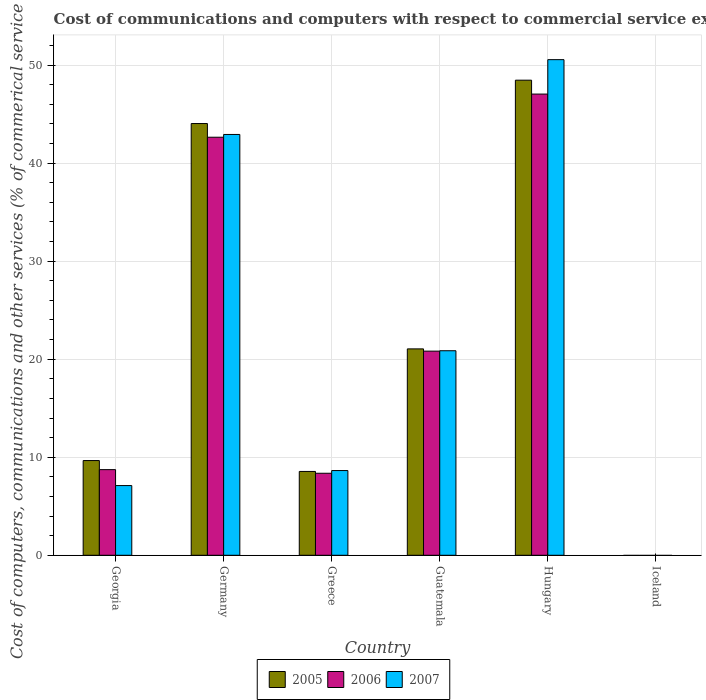How many different coloured bars are there?
Make the answer very short. 3. How many bars are there on the 6th tick from the right?
Offer a very short reply. 3. What is the label of the 6th group of bars from the left?
Offer a terse response. Iceland. What is the cost of communications and computers in 2007 in Guatemala?
Make the answer very short. 20.86. Across all countries, what is the maximum cost of communications and computers in 2005?
Offer a terse response. 48.46. Across all countries, what is the minimum cost of communications and computers in 2007?
Provide a succinct answer. 0. In which country was the cost of communications and computers in 2006 maximum?
Keep it short and to the point. Hungary. What is the total cost of communications and computers in 2005 in the graph?
Keep it short and to the point. 131.75. What is the difference between the cost of communications and computers in 2006 in Guatemala and that in Hungary?
Ensure brevity in your answer.  -26.22. What is the difference between the cost of communications and computers in 2005 in Germany and the cost of communications and computers in 2007 in Guatemala?
Your answer should be very brief. 23.17. What is the average cost of communications and computers in 2006 per country?
Offer a terse response. 21.27. What is the difference between the cost of communications and computers of/in 2006 and cost of communications and computers of/in 2007 in Guatemala?
Ensure brevity in your answer.  -0.04. In how many countries, is the cost of communications and computers in 2007 greater than 42 %?
Keep it short and to the point. 2. What is the ratio of the cost of communications and computers in 2007 in Georgia to that in Guatemala?
Make the answer very short. 0.34. What is the difference between the highest and the second highest cost of communications and computers in 2005?
Your answer should be very brief. 4.42. What is the difference between the highest and the lowest cost of communications and computers in 2005?
Your answer should be compact. 48.46. In how many countries, is the cost of communications and computers in 2007 greater than the average cost of communications and computers in 2007 taken over all countries?
Give a very brief answer. 2. Is it the case that in every country, the sum of the cost of communications and computers in 2005 and cost of communications and computers in 2006 is greater than the cost of communications and computers in 2007?
Your answer should be compact. No. How many bars are there?
Make the answer very short. 15. Are all the bars in the graph horizontal?
Give a very brief answer. No. How many countries are there in the graph?
Offer a very short reply. 6. Does the graph contain grids?
Keep it short and to the point. Yes. How are the legend labels stacked?
Provide a succinct answer. Horizontal. What is the title of the graph?
Offer a very short reply. Cost of communications and computers with respect to commercial service exports. What is the label or title of the X-axis?
Keep it short and to the point. Country. What is the label or title of the Y-axis?
Make the answer very short. Cost of computers, communications and other services (% of commerical service exports). What is the Cost of computers, communications and other services (% of commerical service exports) in 2005 in Georgia?
Offer a very short reply. 9.66. What is the Cost of computers, communications and other services (% of commerical service exports) in 2006 in Georgia?
Make the answer very short. 8.74. What is the Cost of computers, communications and other services (% of commerical service exports) in 2007 in Georgia?
Offer a very short reply. 7.11. What is the Cost of computers, communications and other services (% of commerical service exports) of 2005 in Germany?
Provide a succinct answer. 44.03. What is the Cost of computers, communications and other services (% of commerical service exports) of 2006 in Germany?
Provide a short and direct response. 42.64. What is the Cost of computers, communications and other services (% of commerical service exports) in 2007 in Germany?
Your answer should be very brief. 42.92. What is the Cost of computers, communications and other services (% of commerical service exports) of 2005 in Greece?
Provide a short and direct response. 8.55. What is the Cost of computers, communications and other services (% of commerical service exports) in 2006 in Greece?
Your answer should be very brief. 8.36. What is the Cost of computers, communications and other services (% of commerical service exports) of 2007 in Greece?
Your response must be concise. 8.64. What is the Cost of computers, communications and other services (% of commerical service exports) of 2005 in Guatemala?
Your answer should be very brief. 21.05. What is the Cost of computers, communications and other services (% of commerical service exports) of 2006 in Guatemala?
Give a very brief answer. 20.82. What is the Cost of computers, communications and other services (% of commerical service exports) in 2007 in Guatemala?
Offer a terse response. 20.86. What is the Cost of computers, communications and other services (% of commerical service exports) of 2005 in Hungary?
Provide a short and direct response. 48.46. What is the Cost of computers, communications and other services (% of commerical service exports) in 2006 in Hungary?
Offer a terse response. 47.04. What is the Cost of computers, communications and other services (% of commerical service exports) of 2007 in Hungary?
Offer a very short reply. 50.55. Across all countries, what is the maximum Cost of computers, communications and other services (% of commerical service exports) in 2005?
Offer a terse response. 48.46. Across all countries, what is the maximum Cost of computers, communications and other services (% of commerical service exports) of 2006?
Your response must be concise. 47.04. Across all countries, what is the maximum Cost of computers, communications and other services (% of commerical service exports) of 2007?
Give a very brief answer. 50.55. Across all countries, what is the minimum Cost of computers, communications and other services (% of commerical service exports) of 2005?
Your response must be concise. 0. Across all countries, what is the minimum Cost of computers, communications and other services (% of commerical service exports) of 2006?
Offer a terse response. 0. Across all countries, what is the minimum Cost of computers, communications and other services (% of commerical service exports) in 2007?
Keep it short and to the point. 0. What is the total Cost of computers, communications and other services (% of commerical service exports) of 2005 in the graph?
Ensure brevity in your answer.  131.75. What is the total Cost of computers, communications and other services (% of commerical service exports) in 2006 in the graph?
Your answer should be compact. 127.6. What is the total Cost of computers, communications and other services (% of commerical service exports) of 2007 in the graph?
Your answer should be compact. 130.08. What is the difference between the Cost of computers, communications and other services (% of commerical service exports) of 2005 in Georgia and that in Germany?
Offer a very short reply. -34.37. What is the difference between the Cost of computers, communications and other services (% of commerical service exports) in 2006 in Georgia and that in Germany?
Give a very brief answer. -33.9. What is the difference between the Cost of computers, communications and other services (% of commerical service exports) in 2007 in Georgia and that in Germany?
Ensure brevity in your answer.  -35.81. What is the difference between the Cost of computers, communications and other services (% of commerical service exports) of 2005 in Georgia and that in Greece?
Make the answer very short. 1.11. What is the difference between the Cost of computers, communications and other services (% of commerical service exports) in 2006 in Georgia and that in Greece?
Your answer should be compact. 0.37. What is the difference between the Cost of computers, communications and other services (% of commerical service exports) of 2007 in Georgia and that in Greece?
Keep it short and to the point. -1.53. What is the difference between the Cost of computers, communications and other services (% of commerical service exports) in 2005 in Georgia and that in Guatemala?
Your answer should be compact. -11.39. What is the difference between the Cost of computers, communications and other services (% of commerical service exports) in 2006 in Georgia and that in Guatemala?
Keep it short and to the point. -12.08. What is the difference between the Cost of computers, communications and other services (% of commerical service exports) of 2007 in Georgia and that in Guatemala?
Ensure brevity in your answer.  -13.75. What is the difference between the Cost of computers, communications and other services (% of commerical service exports) in 2005 in Georgia and that in Hungary?
Offer a terse response. -38.8. What is the difference between the Cost of computers, communications and other services (% of commerical service exports) in 2006 in Georgia and that in Hungary?
Give a very brief answer. -38.3. What is the difference between the Cost of computers, communications and other services (% of commerical service exports) of 2007 in Georgia and that in Hungary?
Provide a short and direct response. -43.44. What is the difference between the Cost of computers, communications and other services (% of commerical service exports) in 2005 in Germany and that in Greece?
Give a very brief answer. 35.48. What is the difference between the Cost of computers, communications and other services (% of commerical service exports) of 2006 in Germany and that in Greece?
Provide a succinct answer. 34.27. What is the difference between the Cost of computers, communications and other services (% of commerical service exports) of 2007 in Germany and that in Greece?
Provide a short and direct response. 34.28. What is the difference between the Cost of computers, communications and other services (% of commerical service exports) in 2005 in Germany and that in Guatemala?
Give a very brief answer. 22.98. What is the difference between the Cost of computers, communications and other services (% of commerical service exports) in 2006 in Germany and that in Guatemala?
Provide a short and direct response. 21.82. What is the difference between the Cost of computers, communications and other services (% of commerical service exports) of 2007 in Germany and that in Guatemala?
Provide a succinct answer. 22.06. What is the difference between the Cost of computers, communications and other services (% of commerical service exports) of 2005 in Germany and that in Hungary?
Your answer should be very brief. -4.42. What is the difference between the Cost of computers, communications and other services (% of commerical service exports) in 2006 in Germany and that in Hungary?
Your answer should be compact. -4.4. What is the difference between the Cost of computers, communications and other services (% of commerical service exports) in 2007 in Germany and that in Hungary?
Offer a terse response. -7.63. What is the difference between the Cost of computers, communications and other services (% of commerical service exports) of 2005 in Greece and that in Guatemala?
Keep it short and to the point. -12.5. What is the difference between the Cost of computers, communications and other services (% of commerical service exports) of 2006 in Greece and that in Guatemala?
Give a very brief answer. -12.45. What is the difference between the Cost of computers, communications and other services (% of commerical service exports) of 2007 in Greece and that in Guatemala?
Your answer should be compact. -12.22. What is the difference between the Cost of computers, communications and other services (% of commerical service exports) in 2005 in Greece and that in Hungary?
Your response must be concise. -39.91. What is the difference between the Cost of computers, communications and other services (% of commerical service exports) of 2006 in Greece and that in Hungary?
Make the answer very short. -38.67. What is the difference between the Cost of computers, communications and other services (% of commerical service exports) of 2007 in Greece and that in Hungary?
Your answer should be compact. -41.91. What is the difference between the Cost of computers, communications and other services (% of commerical service exports) of 2005 in Guatemala and that in Hungary?
Provide a short and direct response. -27.41. What is the difference between the Cost of computers, communications and other services (% of commerical service exports) of 2006 in Guatemala and that in Hungary?
Provide a succinct answer. -26.22. What is the difference between the Cost of computers, communications and other services (% of commerical service exports) in 2007 in Guatemala and that in Hungary?
Your answer should be compact. -29.69. What is the difference between the Cost of computers, communications and other services (% of commerical service exports) in 2005 in Georgia and the Cost of computers, communications and other services (% of commerical service exports) in 2006 in Germany?
Your response must be concise. -32.98. What is the difference between the Cost of computers, communications and other services (% of commerical service exports) in 2005 in Georgia and the Cost of computers, communications and other services (% of commerical service exports) in 2007 in Germany?
Provide a short and direct response. -33.26. What is the difference between the Cost of computers, communications and other services (% of commerical service exports) of 2006 in Georgia and the Cost of computers, communications and other services (% of commerical service exports) of 2007 in Germany?
Give a very brief answer. -34.18. What is the difference between the Cost of computers, communications and other services (% of commerical service exports) in 2005 in Georgia and the Cost of computers, communications and other services (% of commerical service exports) in 2006 in Greece?
Your answer should be compact. 1.3. What is the difference between the Cost of computers, communications and other services (% of commerical service exports) in 2005 in Georgia and the Cost of computers, communications and other services (% of commerical service exports) in 2007 in Greece?
Your answer should be compact. 1.02. What is the difference between the Cost of computers, communications and other services (% of commerical service exports) of 2006 in Georgia and the Cost of computers, communications and other services (% of commerical service exports) of 2007 in Greece?
Offer a very short reply. 0.1. What is the difference between the Cost of computers, communications and other services (% of commerical service exports) of 2005 in Georgia and the Cost of computers, communications and other services (% of commerical service exports) of 2006 in Guatemala?
Make the answer very short. -11.16. What is the difference between the Cost of computers, communications and other services (% of commerical service exports) in 2005 in Georgia and the Cost of computers, communications and other services (% of commerical service exports) in 2007 in Guatemala?
Offer a terse response. -11.2. What is the difference between the Cost of computers, communications and other services (% of commerical service exports) in 2006 in Georgia and the Cost of computers, communications and other services (% of commerical service exports) in 2007 in Guatemala?
Keep it short and to the point. -12.13. What is the difference between the Cost of computers, communications and other services (% of commerical service exports) in 2005 in Georgia and the Cost of computers, communications and other services (% of commerical service exports) in 2006 in Hungary?
Your response must be concise. -37.38. What is the difference between the Cost of computers, communications and other services (% of commerical service exports) of 2005 in Georgia and the Cost of computers, communications and other services (% of commerical service exports) of 2007 in Hungary?
Ensure brevity in your answer.  -40.89. What is the difference between the Cost of computers, communications and other services (% of commerical service exports) in 2006 in Georgia and the Cost of computers, communications and other services (% of commerical service exports) in 2007 in Hungary?
Offer a very short reply. -41.81. What is the difference between the Cost of computers, communications and other services (% of commerical service exports) of 2005 in Germany and the Cost of computers, communications and other services (% of commerical service exports) of 2006 in Greece?
Ensure brevity in your answer.  35.67. What is the difference between the Cost of computers, communications and other services (% of commerical service exports) of 2005 in Germany and the Cost of computers, communications and other services (% of commerical service exports) of 2007 in Greece?
Your answer should be compact. 35.39. What is the difference between the Cost of computers, communications and other services (% of commerical service exports) of 2006 in Germany and the Cost of computers, communications and other services (% of commerical service exports) of 2007 in Greece?
Your response must be concise. 34. What is the difference between the Cost of computers, communications and other services (% of commerical service exports) of 2005 in Germany and the Cost of computers, communications and other services (% of commerical service exports) of 2006 in Guatemala?
Your answer should be very brief. 23.21. What is the difference between the Cost of computers, communications and other services (% of commerical service exports) in 2005 in Germany and the Cost of computers, communications and other services (% of commerical service exports) in 2007 in Guatemala?
Ensure brevity in your answer.  23.17. What is the difference between the Cost of computers, communications and other services (% of commerical service exports) of 2006 in Germany and the Cost of computers, communications and other services (% of commerical service exports) of 2007 in Guatemala?
Offer a terse response. 21.78. What is the difference between the Cost of computers, communications and other services (% of commerical service exports) of 2005 in Germany and the Cost of computers, communications and other services (% of commerical service exports) of 2006 in Hungary?
Your answer should be very brief. -3.01. What is the difference between the Cost of computers, communications and other services (% of commerical service exports) of 2005 in Germany and the Cost of computers, communications and other services (% of commerical service exports) of 2007 in Hungary?
Your answer should be very brief. -6.52. What is the difference between the Cost of computers, communications and other services (% of commerical service exports) of 2006 in Germany and the Cost of computers, communications and other services (% of commerical service exports) of 2007 in Hungary?
Your response must be concise. -7.91. What is the difference between the Cost of computers, communications and other services (% of commerical service exports) in 2005 in Greece and the Cost of computers, communications and other services (% of commerical service exports) in 2006 in Guatemala?
Provide a succinct answer. -12.27. What is the difference between the Cost of computers, communications and other services (% of commerical service exports) of 2005 in Greece and the Cost of computers, communications and other services (% of commerical service exports) of 2007 in Guatemala?
Make the answer very short. -12.31. What is the difference between the Cost of computers, communications and other services (% of commerical service exports) of 2006 in Greece and the Cost of computers, communications and other services (% of commerical service exports) of 2007 in Guatemala?
Keep it short and to the point. -12.5. What is the difference between the Cost of computers, communications and other services (% of commerical service exports) in 2005 in Greece and the Cost of computers, communications and other services (% of commerical service exports) in 2006 in Hungary?
Your answer should be very brief. -38.49. What is the difference between the Cost of computers, communications and other services (% of commerical service exports) of 2005 in Greece and the Cost of computers, communications and other services (% of commerical service exports) of 2007 in Hungary?
Your response must be concise. -42. What is the difference between the Cost of computers, communications and other services (% of commerical service exports) in 2006 in Greece and the Cost of computers, communications and other services (% of commerical service exports) in 2007 in Hungary?
Your answer should be compact. -42.18. What is the difference between the Cost of computers, communications and other services (% of commerical service exports) of 2005 in Guatemala and the Cost of computers, communications and other services (% of commerical service exports) of 2006 in Hungary?
Your response must be concise. -25.99. What is the difference between the Cost of computers, communications and other services (% of commerical service exports) in 2005 in Guatemala and the Cost of computers, communications and other services (% of commerical service exports) in 2007 in Hungary?
Your answer should be very brief. -29.5. What is the difference between the Cost of computers, communications and other services (% of commerical service exports) in 2006 in Guatemala and the Cost of computers, communications and other services (% of commerical service exports) in 2007 in Hungary?
Your answer should be very brief. -29.73. What is the average Cost of computers, communications and other services (% of commerical service exports) in 2005 per country?
Offer a terse response. 21.96. What is the average Cost of computers, communications and other services (% of commerical service exports) of 2006 per country?
Provide a short and direct response. 21.27. What is the average Cost of computers, communications and other services (% of commerical service exports) of 2007 per country?
Give a very brief answer. 21.68. What is the difference between the Cost of computers, communications and other services (% of commerical service exports) of 2005 and Cost of computers, communications and other services (% of commerical service exports) of 2006 in Georgia?
Offer a very short reply. 0.93. What is the difference between the Cost of computers, communications and other services (% of commerical service exports) of 2005 and Cost of computers, communications and other services (% of commerical service exports) of 2007 in Georgia?
Offer a terse response. 2.55. What is the difference between the Cost of computers, communications and other services (% of commerical service exports) in 2006 and Cost of computers, communications and other services (% of commerical service exports) in 2007 in Georgia?
Your answer should be very brief. 1.63. What is the difference between the Cost of computers, communications and other services (% of commerical service exports) of 2005 and Cost of computers, communications and other services (% of commerical service exports) of 2006 in Germany?
Keep it short and to the point. 1.4. What is the difference between the Cost of computers, communications and other services (% of commerical service exports) in 2005 and Cost of computers, communications and other services (% of commerical service exports) in 2007 in Germany?
Your answer should be compact. 1.11. What is the difference between the Cost of computers, communications and other services (% of commerical service exports) in 2006 and Cost of computers, communications and other services (% of commerical service exports) in 2007 in Germany?
Give a very brief answer. -0.28. What is the difference between the Cost of computers, communications and other services (% of commerical service exports) of 2005 and Cost of computers, communications and other services (% of commerical service exports) of 2006 in Greece?
Your answer should be compact. 0.19. What is the difference between the Cost of computers, communications and other services (% of commerical service exports) of 2005 and Cost of computers, communications and other services (% of commerical service exports) of 2007 in Greece?
Provide a short and direct response. -0.09. What is the difference between the Cost of computers, communications and other services (% of commerical service exports) of 2006 and Cost of computers, communications and other services (% of commerical service exports) of 2007 in Greece?
Provide a succinct answer. -0.28. What is the difference between the Cost of computers, communications and other services (% of commerical service exports) in 2005 and Cost of computers, communications and other services (% of commerical service exports) in 2006 in Guatemala?
Keep it short and to the point. 0.23. What is the difference between the Cost of computers, communications and other services (% of commerical service exports) in 2005 and Cost of computers, communications and other services (% of commerical service exports) in 2007 in Guatemala?
Your answer should be very brief. 0.19. What is the difference between the Cost of computers, communications and other services (% of commerical service exports) in 2006 and Cost of computers, communications and other services (% of commerical service exports) in 2007 in Guatemala?
Your response must be concise. -0.04. What is the difference between the Cost of computers, communications and other services (% of commerical service exports) in 2005 and Cost of computers, communications and other services (% of commerical service exports) in 2006 in Hungary?
Give a very brief answer. 1.42. What is the difference between the Cost of computers, communications and other services (% of commerical service exports) in 2005 and Cost of computers, communications and other services (% of commerical service exports) in 2007 in Hungary?
Your response must be concise. -2.09. What is the difference between the Cost of computers, communications and other services (% of commerical service exports) in 2006 and Cost of computers, communications and other services (% of commerical service exports) in 2007 in Hungary?
Your answer should be very brief. -3.51. What is the ratio of the Cost of computers, communications and other services (% of commerical service exports) of 2005 in Georgia to that in Germany?
Give a very brief answer. 0.22. What is the ratio of the Cost of computers, communications and other services (% of commerical service exports) in 2006 in Georgia to that in Germany?
Provide a succinct answer. 0.2. What is the ratio of the Cost of computers, communications and other services (% of commerical service exports) of 2007 in Georgia to that in Germany?
Make the answer very short. 0.17. What is the ratio of the Cost of computers, communications and other services (% of commerical service exports) in 2005 in Georgia to that in Greece?
Ensure brevity in your answer.  1.13. What is the ratio of the Cost of computers, communications and other services (% of commerical service exports) of 2006 in Georgia to that in Greece?
Ensure brevity in your answer.  1.04. What is the ratio of the Cost of computers, communications and other services (% of commerical service exports) of 2007 in Georgia to that in Greece?
Your answer should be very brief. 0.82. What is the ratio of the Cost of computers, communications and other services (% of commerical service exports) of 2005 in Georgia to that in Guatemala?
Offer a very short reply. 0.46. What is the ratio of the Cost of computers, communications and other services (% of commerical service exports) in 2006 in Georgia to that in Guatemala?
Give a very brief answer. 0.42. What is the ratio of the Cost of computers, communications and other services (% of commerical service exports) of 2007 in Georgia to that in Guatemala?
Provide a short and direct response. 0.34. What is the ratio of the Cost of computers, communications and other services (% of commerical service exports) of 2005 in Georgia to that in Hungary?
Offer a terse response. 0.2. What is the ratio of the Cost of computers, communications and other services (% of commerical service exports) in 2006 in Georgia to that in Hungary?
Provide a short and direct response. 0.19. What is the ratio of the Cost of computers, communications and other services (% of commerical service exports) of 2007 in Georgia to that in Hungary?
Provide a short and direct response. 0.14. What is the ratio of the Cost of computers, communications and other services (% of commerical service exports) in 2005 in Germany to that in Greece?
Your answer should be very brief. 5.15. What is the ratio of the Cost of computers, communications and other services (% of commerical service exports) in 2006 in Germany to that in Greece?
Offer a very short reply. 5.1. What is the ratio of the Cost of computers, communications and other services (% of commerical service exports) of 2007 in Germany to that in Greece?
Offer a terse response. 4.97. What is the ratio of the Cost of computers, communications and other services (% of commerical service exports) of 2005 in Germany to that in Guatemala?
Offer a terse response. 2.09. What is the ratio of the Cost of computers, communications and other services (% of commerical service exports) of 2006 in Germany to that in Guatemala?
Your answer should be very brief. 2.05. What is the ratio of the Cost of computers, communications and other services (% of commerical service exports) in 2007 in Germany to that in Guatemala?
Make the answer very short. 2.06. What is the ratio of the Cost of computers, communications and other services (% of commerical service exports) of 2005 in Germany to that in Hungary?
Keep it short and to the point. 0.91. What is the ratio of the Cost of computers, communications and other services (% of commerical service exports) in 2006 in Germany to that in Hungary?
Your answer should be compact. 0.91. What is the ratio of the Cost of computers, communications and other services (% of commerical service exports) in 2007 in Germany to that in Hungary?
Ensure brevity in your answer.  0.85. What is the ratio of the Cost of computers, communications and other services (% of commerical service exports) of 2005 in Greece to that in Guatemala?
Offer a very short reply. 0.41. What is the ratio of the Cost of computers, communications and other services (% of commerical service exports) of 2006 in Greece to that in Guatemala?
Give a very brief answer. 0.4. What is the ratio of the Cost of computers, communications and other services (% of commerical service exports) of 2007 in Greece to that in Guatemala?
Provide a succinct answer. 0.41. What is the ratio of the Cost of computers, communications and other services (% of commerical service exports) of 2005 in Greece to that in Hungary?
Offer a terse response. 0.18. What is the ratio of the Cost of computers, communications and other services (% of commerical service exports) in 2006 in Greece to that in Hungary?
Ensure brevity in your answer.  0.18. What is the ratio of the Cost of computers, communications and other services (% of commerical service exports) of 2007 in Greece to that in Hungary?
Your response must be concise. 0.17. What is the ratio of the Cost of computers, communications and other services (% of commerical service exports) of 2005 in Guatemala to that in Hungary?
Make the answer very short. 0.43. What is the ratio of the Cost of computers, communications and other services (% of commerical service exports) in 2006 in Guatemala to that in Hungary?
Keep it short and to the point. 0.44. What is the ratio of the Cost of computers, communications and other services (% of commerical service exports) of 2007 in Guatemala to that in Hungary?
Your answer should be compact. 0.41. What is the difference between the highest and the second highest Cost of computers, communications and other services (% of commerical service exports) in 2005?
Keep it short and to the point. 4.42. What is the difference between the highest and the second highest Cost of computers, communications and other services (% of commerical service exports) in 2006?
Offer a terse response. 4.4. What is the difference between the highest and the second highest Cost of computers, communications and other services (% of commerical service exports) in 2007?
Ensure brevity in your answer.  7.63. What is the difference between the highest and the lowest Cost of computers, communications and other services (% of commerical service exports) in 2005?
Offer a very short reply. 48.46. What is the difference between the highest and the lowest Cost of computers, communications and other services (% of commerical service exports) of 2006?
Keep it short and to the point. 47.04. What is the difference between the highest and the lowest Cost of computers, communications and other services (% of commerical service exports) of 2007?
Ensure brevity in your answer.  50.55. 